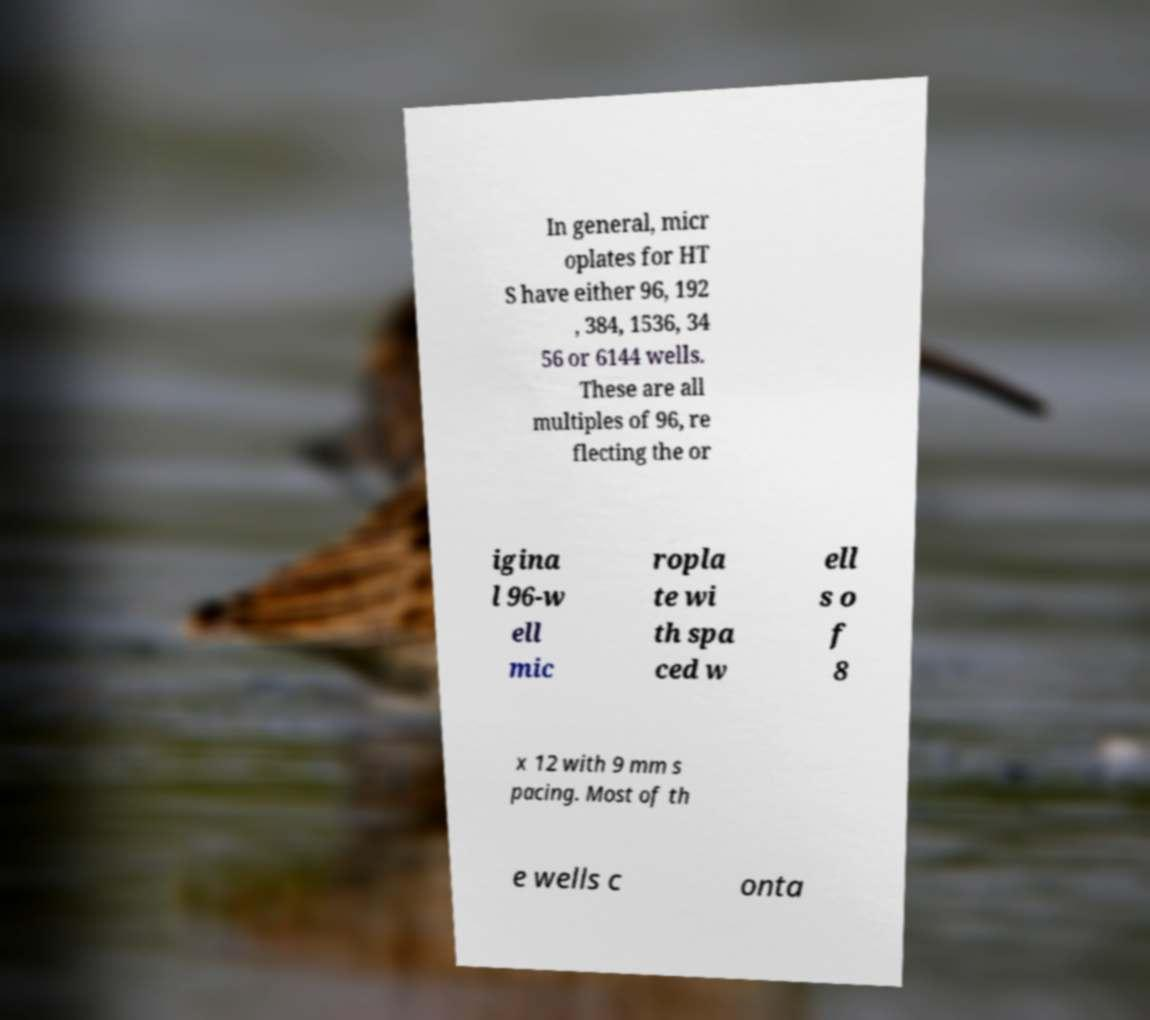Can you read and provide the text displayed in the image?This photo seems to have some interesting text. Can you extract and type it out for me? In general, micr oplates for HT S have either 96, 192 , 384, 1536, 34 56 or 6144 wells. These are all multiples of 96, re flecting the or igina l 96-w ell mic ropla te wi th spa ced w ell s o f 8 x 12 with 9 mm s pacing. Most of th e wells c onta 